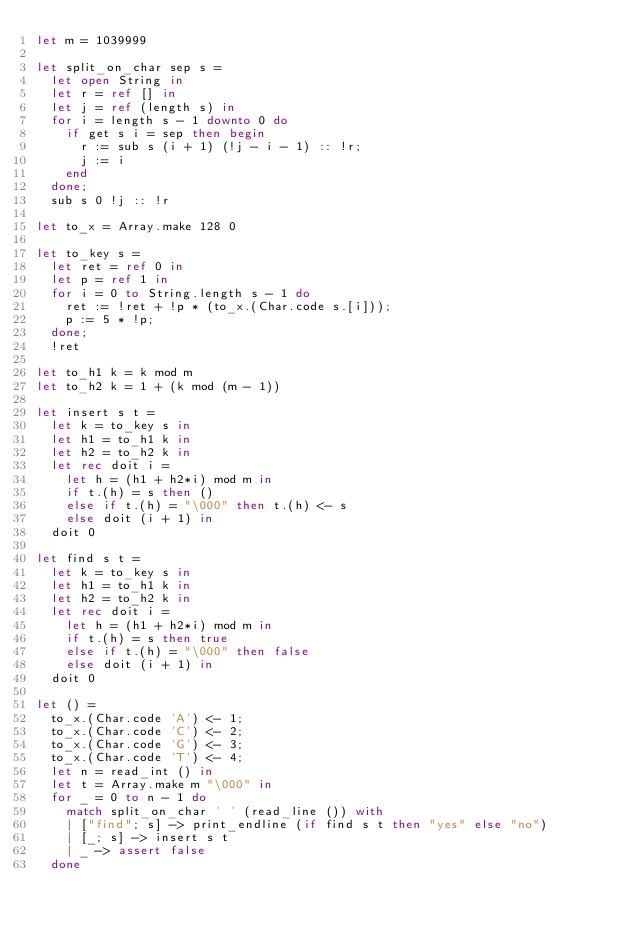<code> <loc_0><loc_0><loc_500><loc_500><_OCaml_>let m = 1039999

let split_on_char sep s =
  let open String in
  let r = ref [] in
  let j = ref (length s) in
  for i = length s - 1 downto 0 do
    if get s i = sep then begin
      r := sub s (i + 1) (!j - i - 1) :: !r;
      j := i
    end
  done;
  sub s 0 !j :: !r

let to_x = Array.make 128 0

let to_key s =
  let ret = ref 0 in
  let p = ref 1 in
  for i = 0 to String.length s - 1 do
    ret := !ret + !p * (to_x.(Char.code s.[i]));
    p := 5 * !p;
  done;
  !ret

let to_h1 k = k mod m
let to_h2 k = 1 + (k mod (m - 1))

let insert s t =
  let k = to_key s in
  let h1 = to_h1 k in
  let h2 = to_h2 k in
  let rec doit i =
    let h = (h1 + h2*i) mod m in
    if t.(h) = s then ()
    else if t.(h) = "\000" then t.(h) <- s
    else doit (i + 1) in
  doit 0

let find s t =
  let k = to_key s in
  let h1 = to_h1 k in
  let h2 = to_h2 k in
  let rec doit i =
    let h = (h1 + h2*i) mod m in
    if t.(h) = s then true
    else if t.(h) = "\000" then false
    else doit (i + 1) in
  doit 0

let () =
  to_x.(Char.code 'A') <- 1;
  to_x.(Char.code 'C') <- 2;
  to_x.(Char.code 'G') <- 3;
  to_x.(Char.code 'T') <- 4;
  let n = read_int () in
  let t = Array.make m "\000" in
  for _ = 0 to n - 1 do
    match split_on_char ' ' (read_line ()) with
    | ["find"; s] -> print_endline (if find s t then "yes" else "no")
    | [_; s] -> insert s t
    | _ -> assert false
  done</code> 